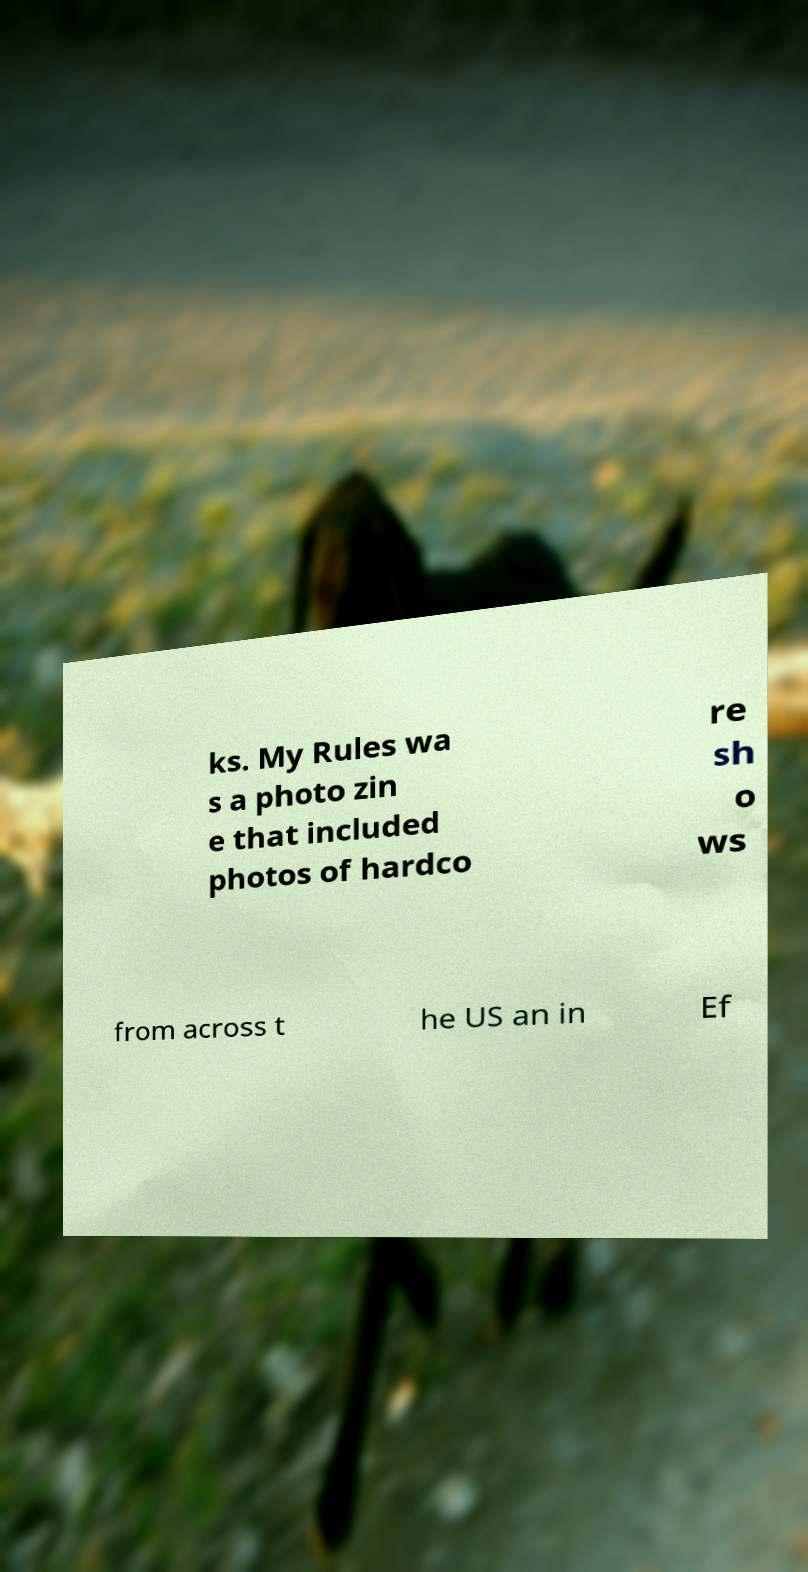Can you accurately transcribe the text from the provided image for me? ks. My Rules wa s a photo zin e that included photos of hardco re sh o ws from across t he US an in Ef 